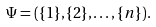Convert formula to latex. <formula><loc_0><loc_0><loc_500><loc_500>\Psi = ( \{ 1 \} , \{ 2 \} , \dots , \{ n \} ) .</formula> 